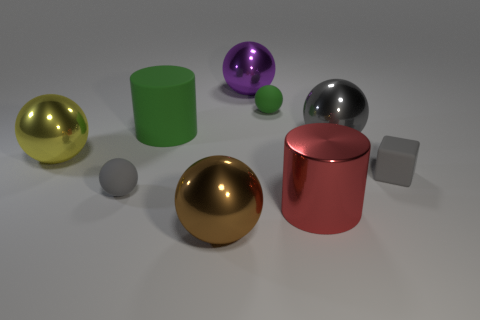Can you describe the sizes and colors of the different spheres in this image? Certainly! In the image, there are four spheres of varying sizes. Starting with the largest, there's a yellow shiny sphere, then a slightly smaller purple sphere, followed by a mid-sized reflective metal sphere, and finally, the smallest one is a green sphere. 